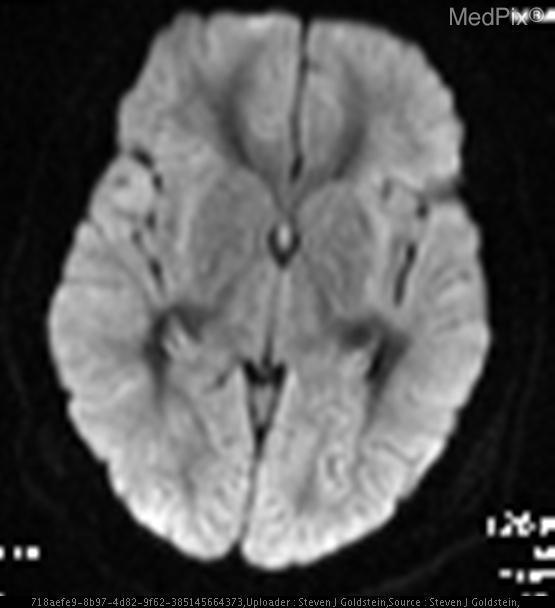What type of image is this?
Give a very brief answer. Mri-dwi. Are there abnormalities with in the contrast between white and grey matter?
Short answer required. Yes. Is the gray-white matter junction altered?
Write a very short answer. Yes. Is the image in the axial plane?
Concise answer only. Yes. Are the ventricles smaller than normal?
Give a very brief answer. Yes. Are the ventricles unaltered?
Be succinct. No. Are the ventricles normal?
Short answer required. No. The bottom of the image indicates what area of the brain?
Keep it brief. Posterior brain. What injury does this brain image suggest?
Be succinct. Hypoxic ischemic injury. What is evinced by this brain image?
Be succinct. Loss of normal gray-white matter junction. 